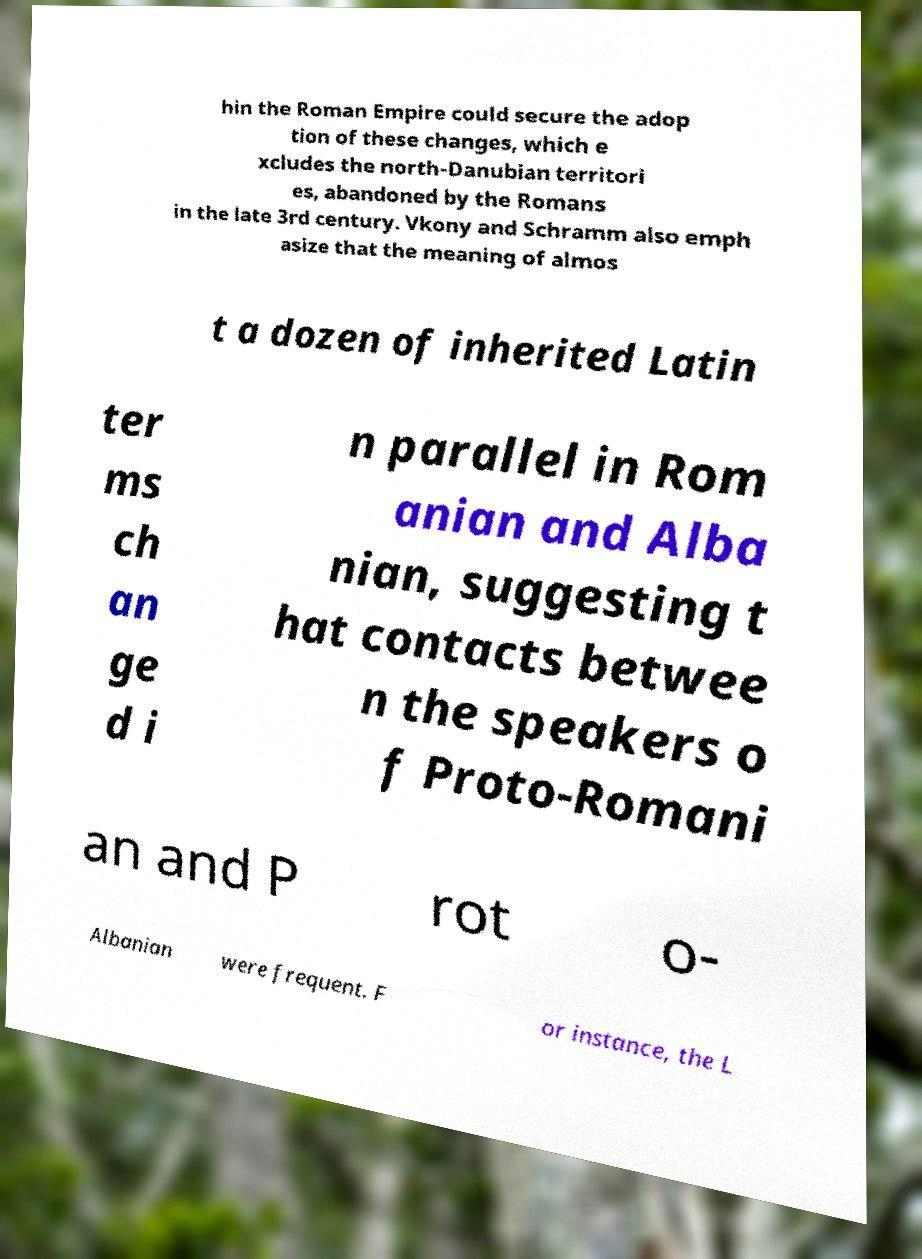Can you read and provide the text displayed in the image?This photo seems to have some interesting text. Can you extract and type it out for me? hin the Roman Empire could secure the adop tion of these changes, which e xcludes the north-Danubian territori es, abandoned by the Romans in the late 3rd century. Vkony and Schramm also emph asize that the meaning of almos t a dozen of inherited Latin ter ms ch an ge d i n parallel in Rom anian and Alba nian, suggesting t hat contacts betwee n the speakers o f Proto-Romani an and P rot o- Albanian were frequent. F or instance, the L 